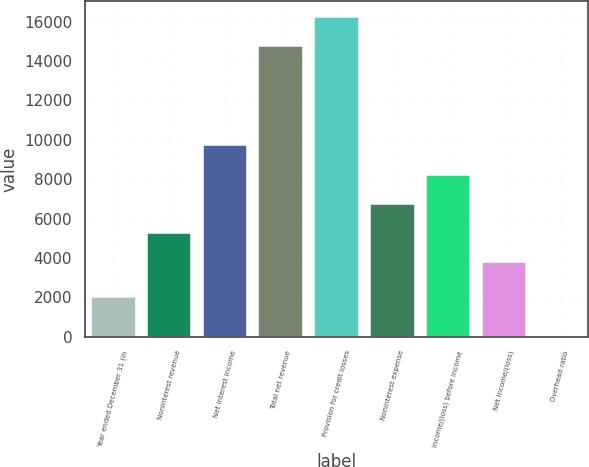Convert chart to OTSL. <chart><loc_0><loc_0><loc_500><loc_500><bar_chart><fcel>Year ended December 31 (in<fcel>Noninterest revenue<fcel>Net interest income<fcel>Total net revenue<fcel>Provision for credit losses<fcel>Noninterest expense<fcel>Income/(loss) before income<fcel>Net income/(loss)<fcel>Overhead ratio<nl><fcel>2009<fcel>5281.5<fcel>9711<fcel>14742<fcel>16217.5<fcel>6757<fcel>8232.5<fcel>3806<fcel>43<nl></chart> 